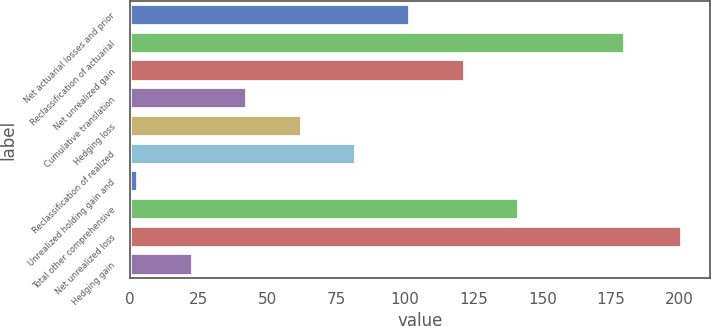<chart> <loc_0><loc_0><loc_500><loc_500><bar_chart><fcel>Net actuarial losses and prior<fcel>Reclassification of actuarial<fcel>Net unrealized gain<fcel>Cumulative translation<fcel>Hedging loss<fcel>Reclassification of realized<fcel>Unrealized holding gain and<fcel>Total other comprehensive<fcel>Net unrealized loss<fcel>Hedging gain<nl><fcel>102<fcel>180<fcel>121.8<fcel>42.6<fcel>62.4<fcel>82.2<fcel>3<fcel>141.6<fcel>201<fcel>22.8<nl></chart> 